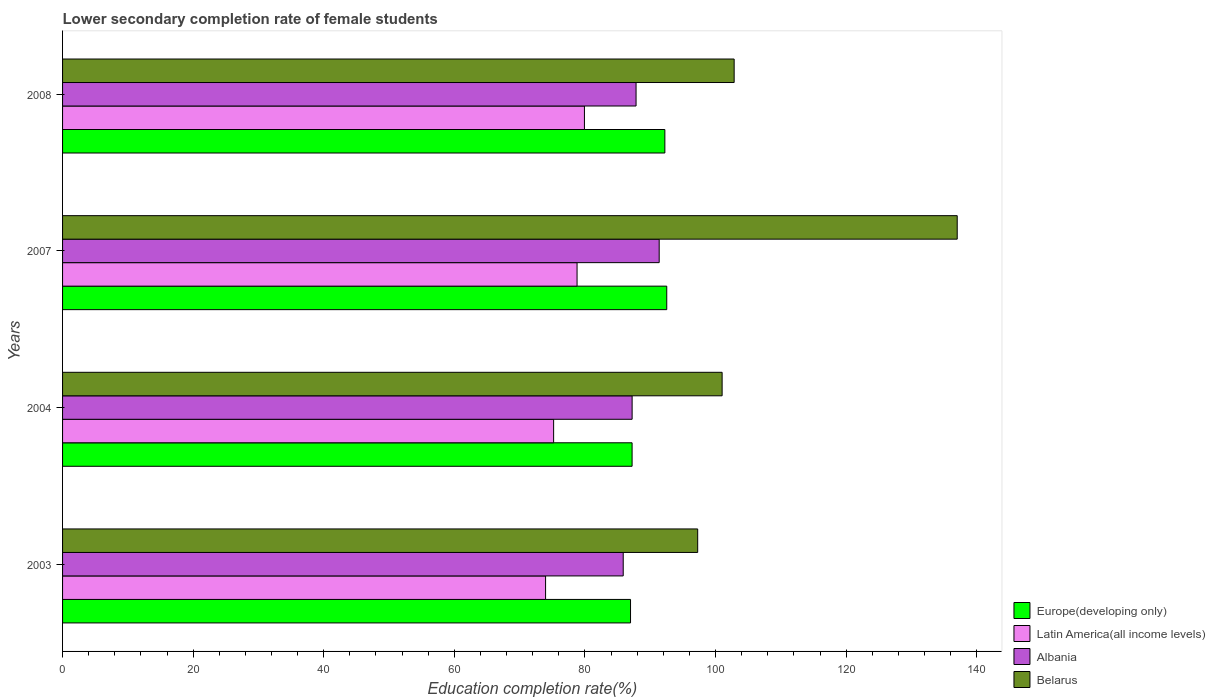How many different coloured bars are there?
Your answer should be compact. 4. How many groups of bars are there?
Offer a very short reply. 4. Are the number of bars per tick equal to the number of legend labels?
Provide a succinct answer. Yes. Are the number of bars on each tick of the Y-axis equal?
Your answer should be very brief. Yes. How many bars are there on the 2nd tick from the bottom?
Your answer should be very brief. 4. What is the lower secondary completion rate of female students in Latin America(all income levels) in 2007?
Provide a short and direct response. 78.8. Across all years, what is the maximum lower secondary completion rate of female students in Europe(developing only)?
Offer a terse response. 92.53. Across all years, what is the minimum lower secondary completion rate of female students in Europe(developing only)?
Ensure brevity in your answer.  86.98. In which year was the lower secondary completion rate of female students in Belarus maximum?
Provide a succinct answer. 2007. In which year was the lower secondary completion rate of female students in Belarus minimum?
Provide a succinct answer. 2003. What is the total lower secondary completion rate of female students in Albania in the graph?
Give a very brief answer. 352.29. What is the difference between the lower secondary completion rate of female students in Albania in 2003 and that in 2007?
Provide a succinct answer. -5.51. What is the difference between the lower secondary completion rate of female students in Latin America(all income levels) in 2004 and the lower secondary completion rate of female students in Europe(developing only) in 2003?
Your answer should be compact. -11.78. What is the average lower secondary completion rate of female students in Albania per year?
Offer a very short reply. 88.07. In the year 2007, what is the difference between the lower secondary completion rate of female students in Belarus and lower secondary completion rate of female students in Europe(developing only)?
Your answer should be compact. 44.48. What is the ratio of the lower secondary completion rate of female students in Belarus in 2004 to that in 2008?
Offer a terse response. 0.98. Is the lower secondary completion rate of female students in Europe(developing only) in 2007 less than that in 2008?
Ensure brevity in your answer.  No. Is the difference between the lower secondary completion rate of female students in Belarus in 2003 and 2007 greater than the difference between the lower secondary completion rate of female students in Europe(developing only) in 2003 and 2007?
Keep it short and to the point. No. What is the difference between the highest and the second highest lower secondary completion rate of female students in Belarus?
Offer a very short reply. 34.16. What is the difference between the highest and the lowest lower secondary completion rate of female students in Albania?
Make the answer very short. 5.51. Is the sum of the lower secondary completion rate of female students in Belarus in 2004 and 2007 greater than the maximum lower secondary completion rate of female students in Albania across all years?
Keep it short and to the point. Yes. What does the 1st bar from the top in 2008 represents?
Keep it short and to the point. Belarus. What does the 2nd bar from the bottom in 2007 represents?
Offer a very short reply. Latin America(all income levels). How many years are there in the graph?
Your answer should be very brief. 4. Are the values on the major ticks of X-axis written in scientific E-notation?
Keep it short and to the point. No. How are the legend labels stacked?
Provide a succinct answer. Vertical. What is the title of the graph?
Your answer should be compact. Lower secondary completion rate of female students. What is the label or title of the X-axis?
Offer a terse response. Education completion rate(%). What is the label or title of the Y-axis?
Your answer should be very brief. Years. What is the Education completion rate(%) in Europe(developing only) in 2003?
Give a very brief answer. 86.98. What is the Education completion rate(%) of Latin America(all income levels) in 2003?
Keep it short and to the point. 73.97. What is the Education completion rate(%) in Albania in 2003?
Offer a very short reply. 85.86. What is the Education completion rate(%) of Belarus in 2003?
Give a very brief answer. 97.27. What is the Education completion rate(%) in Europe(developing only) in 2004?
Provide a succinct answer. 87.22. What is the Education completion rate(%) in Latin America(all income levels) in 2004?
Your answer should be very brief. 75.2. What is the Education completion rate(%) of Albania in 2004?
Provide a succinct answer. 87.23. What is the Education completion rate(%) in Belarus in 2004?
Provide a short and direct response. 101.01. What is the Education completion rate(%) of Europe(developing only) in 2007?
Your answer should be compact. 92.53. What is the Education completion rate(%) in Latin America(all income levels) in 2007?
Your response must be concise. 78.8. What is the Education completion rate(%) in Albania in 2007?
Your answer should be compact. 91.37. What is the Education completion rate(%) in Belarus in 2007?
Keep it short and to the point. 137.01. What is the Education completion rate(%) of Europe(developing only) in 2008?
Provide a succinct answer. 92.24. What is the Education completion rate(%) of Latin America(all income levels) in 2008?
Make the answer very short. 79.92. What is the Education completion rate(%) in Albania in 2008?
Your answer should be compact. 87.83. What is the Education completion rate(%) of Belarus in 2008?
Keep it short and to the point. 102.85. Across all years, what is the maximum Education completion rate(%) in Europe(developing only)?
Your answer should be compact. 92.53. Across all years, what is the maximum Education completion rate(%) in Latin America(all income levels)?
Offer a very short reply. 79.92. Across all years, what is the maximum Education completion rate(%) in Albania?
Your response must be concise. 91.37. Across all years, what is the maximum Education completion rate(%) of Belarus?
Make the answer very short. 137.01. Across all years, what is the minimum Education completion rate(%) in Europe(developing only)?
Make the answer very short. 86.98. Across all years, what is the minimum Education completion rate(%) of Latin America(all income levels)?
Ensure brevity in your answer.  73.97. Across all years, what is the minimum Education completion rate(%) of Albania?
Your answer should be very brief. 85.86. Across all years, what is the minimum Education completion rate(%) in Belarus?
Your answer should be very brief. 97.27. What is the total Education completion rate(%) in Europe(developing only) in the graph?
Keep it short and to the point. 358.98. What is the total Education completion rate(%) of Latin America(all income levels) in the graph?
Provide a short and direct response. 307.9. What is the total Education completion rate(%) in Albania in the graph?
Your answer should be compact. 352.29. What is the total Education completion rate(%) in Belarus in the graph?
Keep it short and to the point. 438.15. What is the difference between the Education completion rate(%) of Europe(developing only) in 2003 and that in 2004?
Your answer should be very brief. -0.24. What is the difference between the Education completion rate(%) of Latin America(all income levels) in 2003 and that in 2004?
Your response must be concise. -1.23. What is the difference between the Education completion rate(%) in Albania in 2003 and that in 2004?
Your answer should be compact. -1.36. What is the difference between the Education completion rate(%) of Belarus in 2003 and that in 2004?
Your response must be concise. -3.74. What is the difference between the Education completion rate(%) of Europe(developing only) in 2003 and that in 2007?
Give a very brief answer. -5.55. What is the difference between the Education completion rate(%) in Latin America(all income levels) in 2003 and that in 2007?
Keep it short and to the point. -4.82. What is the difference between the Education completion rate(%) of Albania in 2003 and that in 2007?
Keep it short and to the point. -5.51. What is the difference between the Education completion rate(%) of Belarus in 2003 and that in 2007?
Your answer should be very brief. -39.75. What is the difference between the Education completion rate(%) of Europe(developing only) in 2003 and that in 2008?
Provide a succinct answer. -5.26. What is the difference between the Education completion rate(%) in Latin America(all income levels) in 2003 and that in 2008?
Provide a succinct answer. -5.95. What is the difference between the Education completion rate(%) of Albania in 2003 and that in 2008?
Your response must be concise. -1.97. What is the difference between the Education completion rate(%) in Belarus in 2003 and that in 2008?
Give a very brief answer. -5.59. What is the difference between the Education completion rate(%) of Europe(developing only) in 2004 and that in 2007?
Provide a succinct answer. -5.31. What is the difference between the Education completion rate(%) of Latin America(all income levels) in 2004 and that in 2007?
Your response must be concise. -3.59. What is the difference between the Education completion rate(%) of Albania in 2004 and that in 2007?
Keep it short and to the point. -4.15. What is the difference between the Education completion rate(%) of Belarus in 2004 and that in 2007?
Offer a terse response. -36. What is the difference between the Education completion rate(%) in Europe(developing only) in 2004 and that in 2008?
Provide a short and direct response. -5.02. What is the difference between the Education completion rate(%) in Latin America(all income levels) in 2004 and that in 2008?
Provide a succinct answer. -4.72. What is the difference between the Education completion rate(%) of Albania in 2004 and that in 2008?
Provide a succinct answer. -0.6. What is the difference between the Education completion rate(%) in Belarus in 2004 and that in 2008?
Ensure brevity in your answer.  -1.84. What is the difference between the Education completion rate(%) of Europe(developing only) in 2007 and that in 2008?
Offer a very short reply. 0.29. What is the difference between the Education completion rate(%) of Latin America(all income levels) in 2007 and that in 2008?
Give a very brief answer. -1.13. What is the difference between the Education completion rate(%) of Albania in 2007 and that in 2008?
Make the answer very short. 3.54. What is the difference between the Education completion rate(%) in Belarus in 2007 and that in 2008?
Make the answer very short. 34.16. What is the difference between the Education completion rate(%) in Europe(developing only) in 2003 and the Education completion rate(%) in Latin America(all income levels) in 2004?
Your answer should be compact. 11.78. What is the difference between the Education completion rate(%) of Europe(developing only) in 2003 and the Education completion rate(%) of Albania in 2004?
Provide a short and direct response. -0.24. What is the difference between the Education completion rate(%) in Europe(developing only) in 2003 and the Education completion rate(%) in Belarus in 2004?
Your answer should be very brief. -14.03. What is the difference between the Education completion rate(%) of Latin America(all income levels) in 2003 and the Education completion rate(%) of Albania in 2004?
Your response must be concise. -13.25. What is the difference between the Education completion rate(%) in Latin America(all income levels) in 2003 and the Education completion rate(%) in Belarus in 2004?
Your answer should be compact. -27.04. What is the difference between the Education completion rate(%) of Albania in 2003 and the Education completion rate(%) of Belarus in 2004?
Your answer should be very brief. -15.15. What is the difference between the Education completion rate(%) in Europe(developing only) in 2003 and the Education completion rate(%) in Latin America(all income levels) in 2007?
Ensure brevity in your answer.  8.19. What is the difference between the Education completion rate(%) in Europe(developing only) in 2003 and the Education completion rate(%) in Albania in 2007?
Your answer should be very brief. -4.39. What is the difference between the Education completion rate(%) in Europe(developing only) in 2003 and the Education completion rate(%) in Belarus in 2007?
Give a very brief answer. -50.03. What is the difference between the Education completion rate(%) of Latin America(all income levels) in 2003 and the Education completion rate(%) of Albania in 2007?
Ensure brevity in your answer.  -17.4. What is the difference between the Education completion rate(%) of Latin America(all income levels) in 2003 and the Education completion rate(%) of Belarus in 2007?
Provide a short and direct response. -63.04. What is the difference between the Education completion rate(%) in Albania in 2003 and the Education completion rate(%) in Belarus in 2007?
Make the answer very short. -51.15. What is the difference between the Education completion rate(%) of Europe(developing only) in 2003 and the Education completion rate(%) of Latin America(all income levels) in 2008?
Your response must be concise. 7.06. What is the difference between the Education completion rate(%) of Europe(developing only) in 2003 and the Education completion rate(%) of Albania in 2008?
Offer a terse response. -0.85. What is the difference between the Education completion rate(%) of Europe(developing only) in 2003 and the Education completion rate(%) of Belarus in 2008?
Provide a succinct answer. -15.87. What is the difference between the Education completion rate(%) of Latin America(all income levels) in 2003 and the Education completion rate(%) of Albania in 2008?
Your answer should be compact. -13.86. What is the difference between the Education completion rate(%) in Latin America(all income levels) in 2003 and the Education completion rate(%) in Belarus in 2008?
Offer a very short reply. -28.88. What is the difference between the Education completion rate(%) of Albania in 2003 and the Education completion rate(%) of Belarus in 2008?
Make the answer very short. -16.99. What is the difference between the Education completion rate(%) of Europe(developing only) in 2004 and the Education completion rate(%) of Latin America(all income levels) in 2007?
Offer a very short reply. 8.43. What is the difference between the Education completion rate(%) of Europe(developing only) in 2004 and the Education completion rate(%) of Albania in 2007?
Your answer should be very brief. -4.15. What is the difference between the Education completion rate(%) of Europe(developing only) in 2004 and the Education completion rate(%) of Belarus in 2007?
Your answer should be very brief. -49.79. What is the difference between the Education completion rate(%) in Latin America(all income levels) in 2004 and the Education completion rate(%) in Albania in 2007?
Keep it short and to the point. -16.17. What is the difference between the Education completion rate(%) of Latin America(all income levels) in 2004 and the Education completion rate(%) of Belarus in 2007?
Your response must be concise. -61.81. What is the difference between the Education completion rate(%) in Albania in 2004 and the Education completion rate(%) in Belarus in 2007?
Give a very brief answer. -49.79. What is the difference between the Education completion rate(%) of Europe(developing only) in 2004 and the Education completion rate(%) of Latin America(all income levels) in 2008?
Offer a very short reply. 7.3. What is the difference between the Education completion rate(%) in Europe(developing only) in 2004 and the Education completion rate(%) in Albania in 2008?
Offer a very short reply. -0.61. What is the difference between the Education completion rate(%) in Europe(developing only) in 2004 and the Education completion rate(%) in Belarus in 2008?
Offer a terse response. -15.63. What is the difference between the Education completion rate(%) of Latin America(all income levels) in 2004 and the Education completion rate(%) of Albania in 2008?
Your answer should be very brief. -12.63. What is the difference between the Education completion rate(%) of Latin America(all income levels) in 2004 and the Education completion rate(%) of Belarus in 2008?
Give a very brief answer. -27.65. What is the difference between the Education completion rate(%) of Albania in 2004 and the Education completion rate(%) of Belarus in 2008?
Provide a succinct answer. -15.63. What is the difference between the Education completion rate(%) of Europe(developing only) in 2007 and the Education completion rate(%) of Latin America(all income levels) in 2008?
Your answer should be compact. 12.61. What is the difference between the Education completion rate(%) of Europe(developing only) in 2007 and the Education completion rate(%) of Albania in 2008?
Ensure brevity in your answer.  4.7. What is the difference between the Education completion rate(%) in Europe(developing only) in 2007 and the Education completion rate(%) in Belarus in 2008?
Your answer should be compact. -10.32. What is the difference between the Education completion rate(%) in Latin America(all income levels) in 2007 and the Education completion rate(%) in Albania in 2008?
Your answer should be compact. -9.03. What is the difference between the Education completion rate(%) of Latin America(all income levels) in 2007 and the Education completion rate(%) of Belarus in 2008?
Provide a succinct answer. -24.06. What is the difference between the Education completion rate(%) in Albania in 2007 and the Education completion rate(%) in Belarus in 2008?
Provide a succinct answer. -11.48. What is the average Education completion rate(%) of Europe(developing only) per year?
Your answer should be compact. 89.74. What is the average Education completion rate(%) in Latin America(all income levels) per year?
Keep it short and to the point. 76.97. What is the average Education completion rate(%) of Albania per year?
Your answer should be compact. 88.07. What is the average Education completion rate(%) in Belarus per year?
Make the answer very short. 109.54. In the year 2003, what is the difference between the Education completion rate(%) of Europe(developing only) and Education completion rate(%) of Latin America(all income levels)?
Make the answer very short. 13.01. In the year 2003, what is the difference between the Education completion rate(%) in Europe(developing only) and Education completion rate(%) in Albania?
Offer a terse response. 1.12. In the year 2003, what is the difference between the Education completion rate(%) of Europe(developing only) and Education completion rate(%) of Belarus?
Your answer should be very brief. -10.28. In the year 2003, what is the difference between the Education completion rate(%) in Latin America(all income levels) and Education completion rate(%) in Albania?
Offer a very short reply. -11.89. In the year 2003, what is the difference between the Education completion rate(%) of Latin America(all income levels) and Education completion rate(%) of Belarus?
Your answer should be very brief. -23.3. In the year 2003, what is the difference between the Education completion rate(%) of Albania and Education completion rate(%) of Belarus?
Your answer should be compact. -11.4. In the year 2004, what is the difference between the Education completion rate(%) in Europe(developing only) and Education completion rate(%) in Latin America(all income levels)?
Provide a succinct answer. 12.02. In the year 2004, what is the difference between the Education completion rate(%) in Europe(developing only) and Education completion rate(%) in Albania?
Make the answer very short. -0. In the year 2004, what is the difference between the Education completion rate(%) of Europe(developing only) and Education completion rate(%) of Belarus?
Provide a succinct answer. -13.79. In the year 2004, what is the difference between the Education completion rate(%) in Latin America(all income levels) and Education completion rate(%) in Albania?
Give a very brief answer. -12.02. In the year 2004, what is the difference between the Education completion rate(%) of Latin America(all income levels) and Education completion rate(%) of Belarus?
Keep it short and to the point. -25.81. In the year 2004, what is the difference between the Education completion rate(%) of Albania and Education completion rate(%) of Belarus?
Ensure brevity in your answer.  -13.78. In the year 2007, what is the difference between the Education completion rate(%) in Europe(developing only) and Education completion rate(%) in Latin America(all income levels)?
Provide a succinct answer. 13.73. In the year 2007, what is the difference between the Education completion rate(%) in Europe(developing only) and Education completion rate(%) in Albania?
Ensure brevity in your answer.  1.16. In the year 2007, what is the difference between the Education completion rate(%) of Europe(developing only) and Education completion rate(%) of Belarus?
Make the answer very short. -44.48. In the year 2007, what is the difference between the Education completion rate(%) of Latin America(all income levels) and Education completion rate(%) of Albania?
Provide a succinct answer. -12.58. In the year 2007, what is the difference between the Education completion rate(%) of Latin America(all income levels) and Education completion rate(%) of Belarus?
Ensure brevity in your answer.  -58.22. In the year 2007, what is the difference between the Education completion rate(%) of Albania and Education completion rate(%) of Belarus?
Provide a succinct answer. -45.64. In the year 2008, what is the difference between the Education completion rate(%) of Europe(developing only) and Education completion rate(%) of Latin America(all income levels)?
Offer a terse response. 12.32. In the year 2008, what is the difference between the Education completion rate(%) in Europe(developing only) and Education completion rate(%) in Albania?
Your answer should be compact. 4.41. In the year 2008, what is the difference between the Education completion rate(%) of Europe(developing only) and Education completion rate(%) of Belarus?
Your answer should be very brief. -10.61. In the year 2008, what is the difference between the Education completion rate(%) of Latin America(all income levels) and Education completion rate(%) of Albania?
Offer a terse response. -7.91. In the year 2008, what is the difference between the Education completion rate(%) of Latin America(all income levels) and Education completion rate(%) of Belarus?
Your answer should be compact. -22.93. In the year 2008, what is the difference between the Education completion rate(%) in Albania and Education completion rate(%) in Belarus?
Offer a terse response. -15.02. What is the ratio of the Education completion rate(%) of Latin America(all income levels) in 2003 to that in 2004?
Ensure brevity in your answer.  0.98. What is the ratio of the Education completion rate(%) of Albania in 2003 to that in 2004?
Keep it short and to the point. 0.98. What is the ratio of the Education completion rate(%) of Belarus in 2003 to that in 2004?
Give a very brief answer. 0.96. What is the ratio of the Education completion rate(%) in Europe(developing only) in 2003 to that in 2007?
Your answer should be compact. 0.94. What is the ratio of the Education completion rate(%) in Latin America(all income levels) in 2003 to that in 2007?
Your answer should be compact. 0.94. What is the ratio of the Education completion rate(%) of Albania in 2003 to that in 2007?
Offer a terse response. 0.94. What is the ratio of the Education completion rate(%) of Belarus in 2003 to that in 2007?
Your answer should be very brief. 0.71. What is the ratio of the Education completion rate(%) in Europe(developing only) in 2003 to that in 2008?
Provide a succinct answer. 0.94. What is the ratio of the Education completion rate(%) of Latin America(all income levels) in 2003 to that in 2008?
Your response must be concise. 0.93. What is the ratio of the Education completion rate(%) in Albania in 2003 to that in 2008?
Your answer should be compact. 0.98. What is the ratio of the Education completion rate(%) in Belarus in 2003 to that in 2008?
Offer a very short reply. 0.95. What is the ratio of the Education completion rate(%) of Europe(developing only) in 2004 to that in 2007?
Your response must be concise. 0.94. What is the ratio of the Education completion rate(%) in Latin America(all income levels) in 2004 to that in 2007?
Make the answer very short. 0.95. What is the ratio of the Education completion rate(%) in Albania in 2004 to that in 2007?
Ensure brevity in your answer.  0.95. What is the ratio of the Education completion rate(%) of Belarus in 2004 to that in 2007?
Your answer should be very brief. 0.74. What is the ratio of the Education completion rate(%) of Europe(developing only) in 2004 to that in 2008?
Keep it short and to the point. 0.95. What is the ratio of the Education completion rate(%) of Latin America(all income levels) in 2004 to that in 2008?
Provide a succinct answer. 0.94. What is the ratio of the Education completion rate(%) of Belarus in 2004 to that in 2008?
Keep it short and to the point. 0.98. What is the ratio of the Education completion rate(%) of Europe(developing only) in 2007 to that in 2008?
Your answer should be compact. 1. What is the ratio of the Education completion rate(%) of Latin America(all income levels) in 2007 to that in 2008?
Keep it short and to the point. 0.99. What is the ratio of the Education completion rate(%) in Albania in 2007 to that in 2008?
Offer a terse response. 1.04. What is the ratio of the Education completion rate(%) of Belarus in 2007 to that in 2008?
Your answer should be compact. 1.33. What is the difference between the highest and the second highest Education completion rate(%) in Europe(developing only)?
Offer a terse response. 0.29. What is the difference between the highest and the second highest Education completion rate(%) in Latin America(all income levels)?
Provide a short and direct response. 1.13. What is the difference between the highest and the second highest Education completion rate(%) in Albania?
Make the answer very short. 3.54. What is the difference between the highest and the second highest Education completion rate(%) of Belarus?
Ensure brevity in your answer.  34.16. What is the difference between the highest and the lowest Education completion rate(%) of Europe(developing only)?
Provide a succinct answer. 5.55. What is the difference between the highest and the lowest Education completion rate(%) of Latin America(all income levels)?
Your answer should be compact. 5.95. What is the difference between the highest and the lowest Education completion rate(%) in Albania?
Make the answer very short. 5.51. What is the difference between the highest and the lowest Education completion rate(%) in Belarus?
Your answer should be compact. 39.75. 